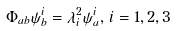Convert formula to latex. <formula><loc_0><loc_0><loc_500><loc_500>\Phi _ { a b } \psi _ { b } ^ { i } = \lambda _ { i } ^ { 2 } \psi _ { a } ^ { i } , \, i = 1 , 2 , 3</formula> 